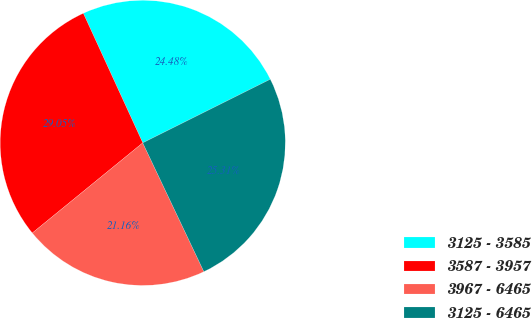Convert chart. <chart><loc_0><loc_0><loc_500><loc_500><pie_chart><fcel>3125 - 3585<fcel>3587 - 3957<fcel>3967 - 6465<fcel>3125 - 6465<nl><fcel>24.48%<fcel>29.05%<fcel>21.16%<fcel>25.31%<nl></chart> 